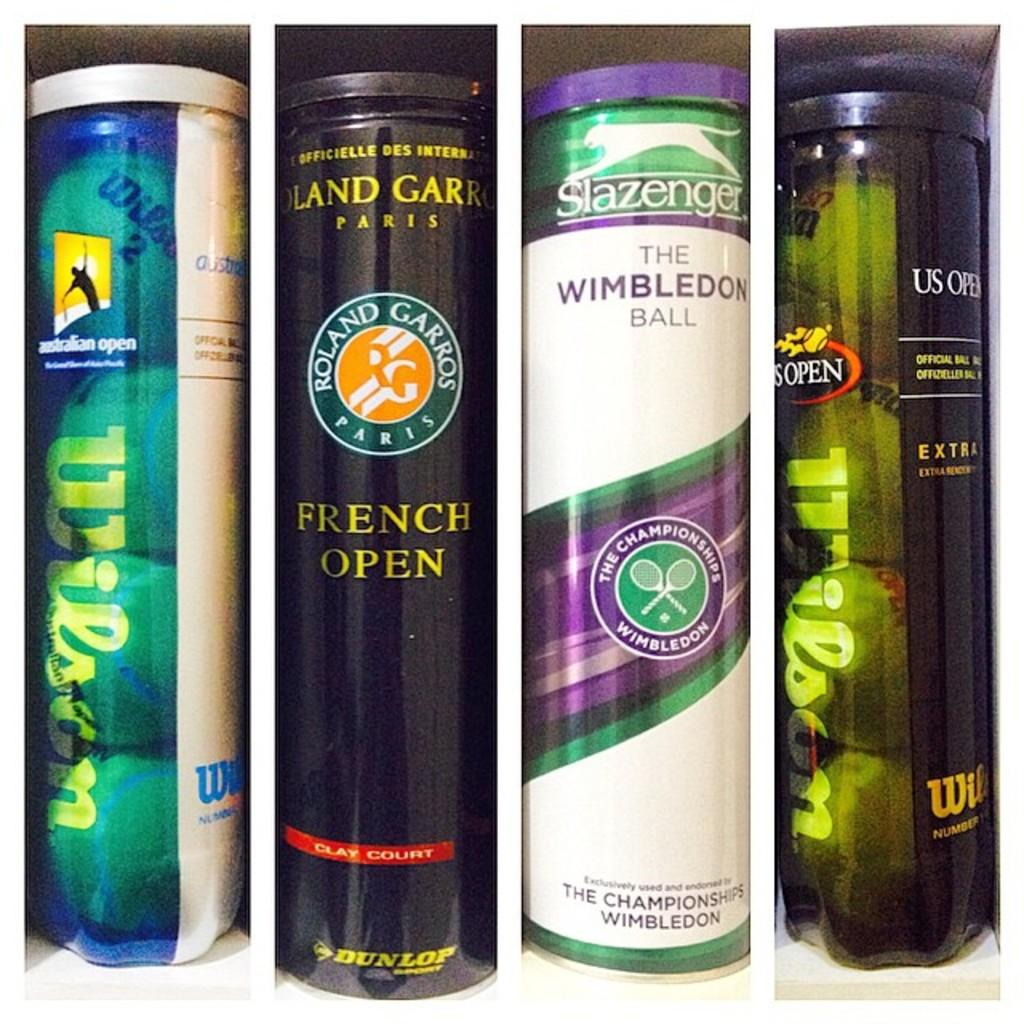<image>
Present a compact description of the photo's key features. Two out of the four containers of tennis balls are the Wilson brand 